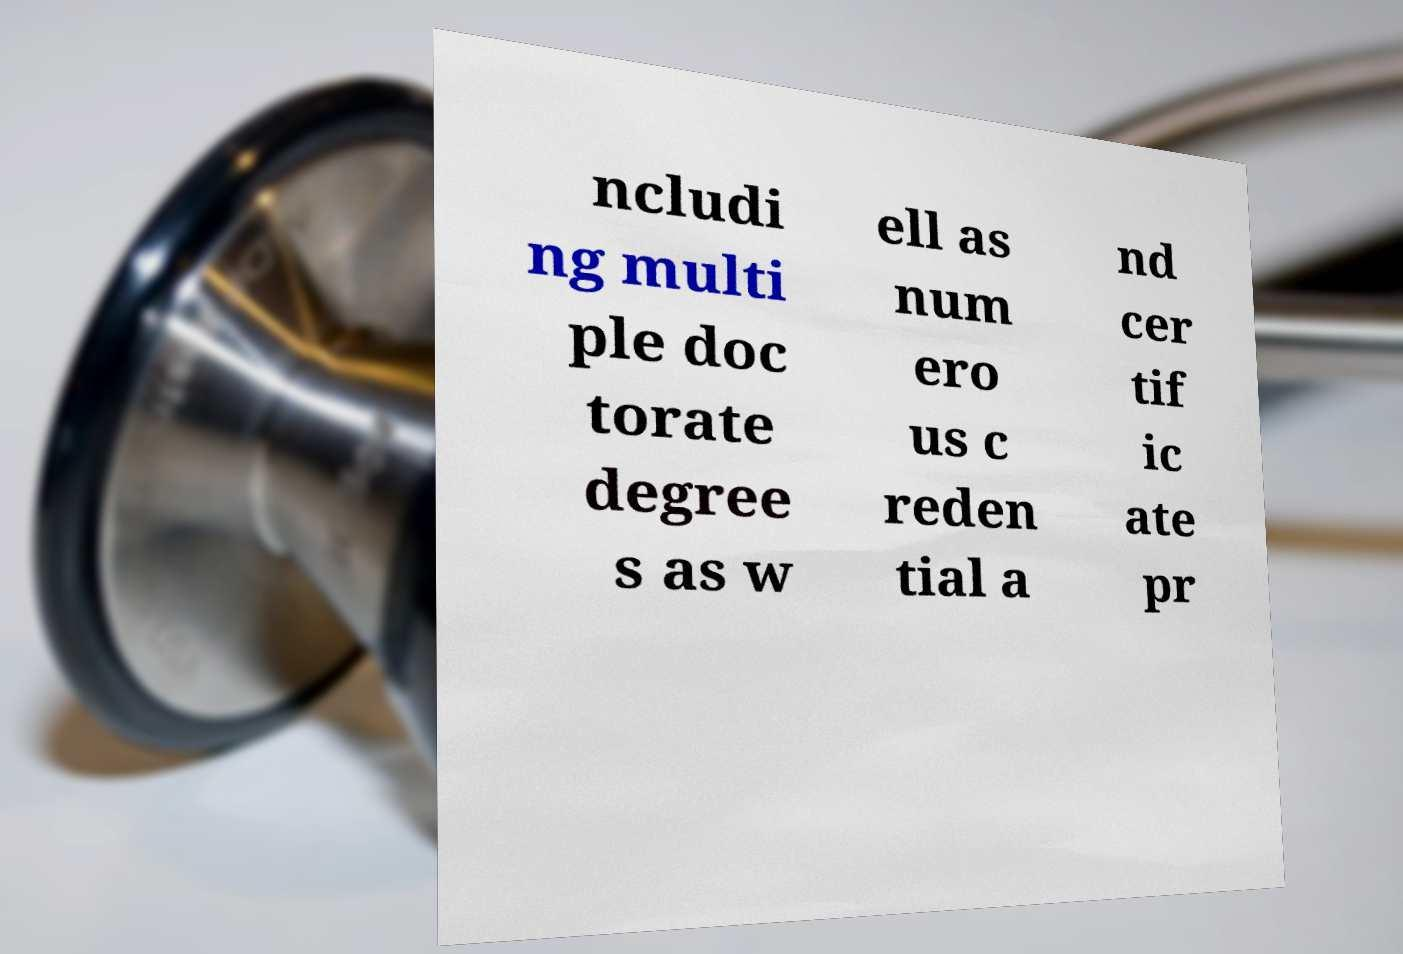For documentation purposes, I need the text within this image transcribed. Could you provide that? ncludi ng multi ple doc torate degree s as w ell as num ero us c reden tial a nd cer tif ic ate pr 